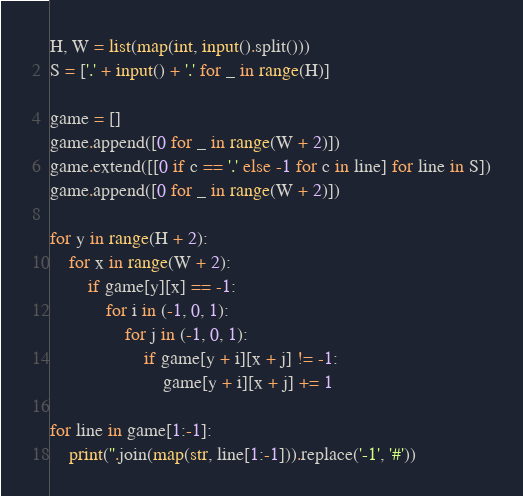<code> <loc_0><loc_0><loc_500><loc_500><_Python_>H, W = list(map(int, input().split()))
S = ['.' + input() + '.' for _ in range(H)]

game = []
game.append([0 for _ in range(W + 2)])
game.extend([[0 if c == '.' else -1 for c in line] for line in S])
game.append([0 for _ in range(W + 2)])

for y in range(H + 2):
    for x in range(W + 2):
        if game[y][x] == -1:
            for i in (-1, 0, 1):
                for j in (-1, 0, 1):
                    if game[y + i][x + j] != -1:
                        game[y + i][x + j] += 1

for line in game[1:-1]:
    print(''.join(map(str, line[1:-1])).replace('-1', '#'))</code> 